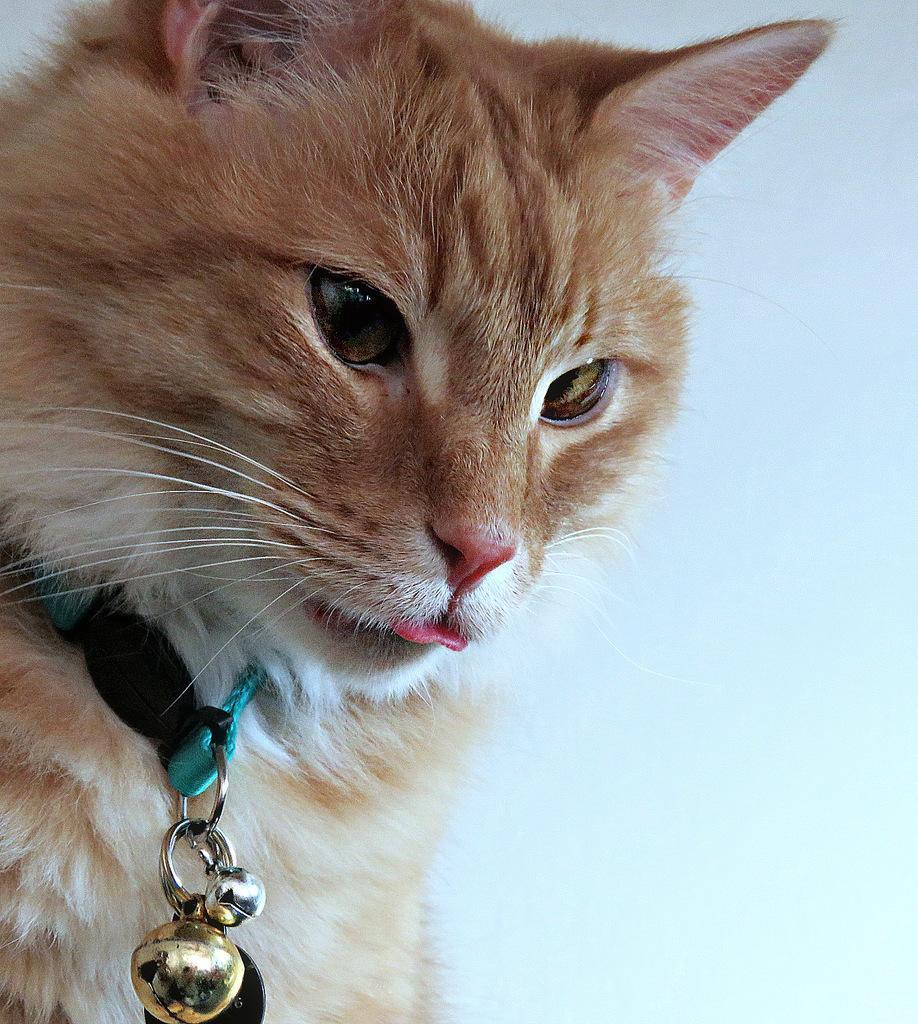How would you summarize this image in a sentence or two? In this image there is a cat, in the background it is blurred. 